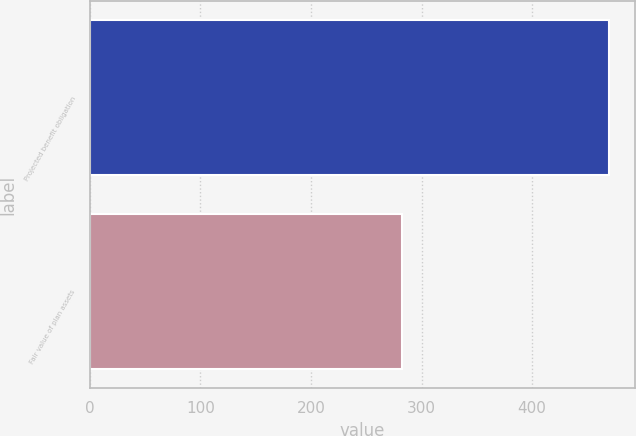<chart> <loc_0><loc_0><loc_500><loc_500><bar_chart><fcel>Projected benefit obligation<fcel>Fair value of plan assets<nl><fcel>470<fcel>282<nl></chart> 